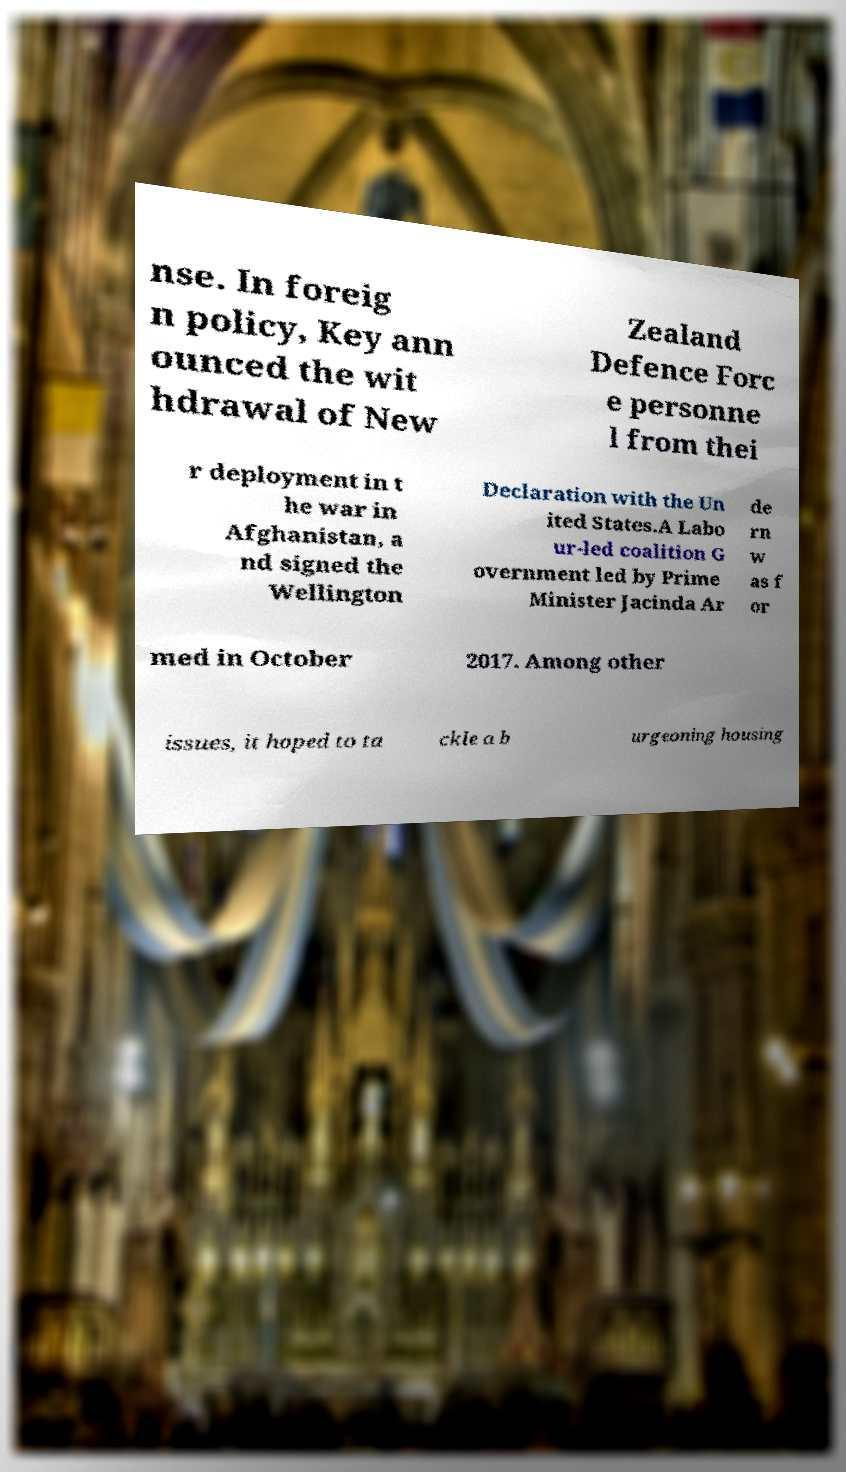For documentation purposes, I need the text within this image transcribed. Could you provide that? nse. In foreig n policy, Key ann ounced the wit hdrawal of New Zealand Defence Forc e personne l from thei r deployment in t he war in Afghanistan, a nd signed the Wellington Declaration with the Un ited States.A Labo ur-led coalition G overnment led by Prime Minister Jacinda Ar de rn w as f or med in October 2017. Among other issues, it hoped to ta ckle a b urgeoning housing 